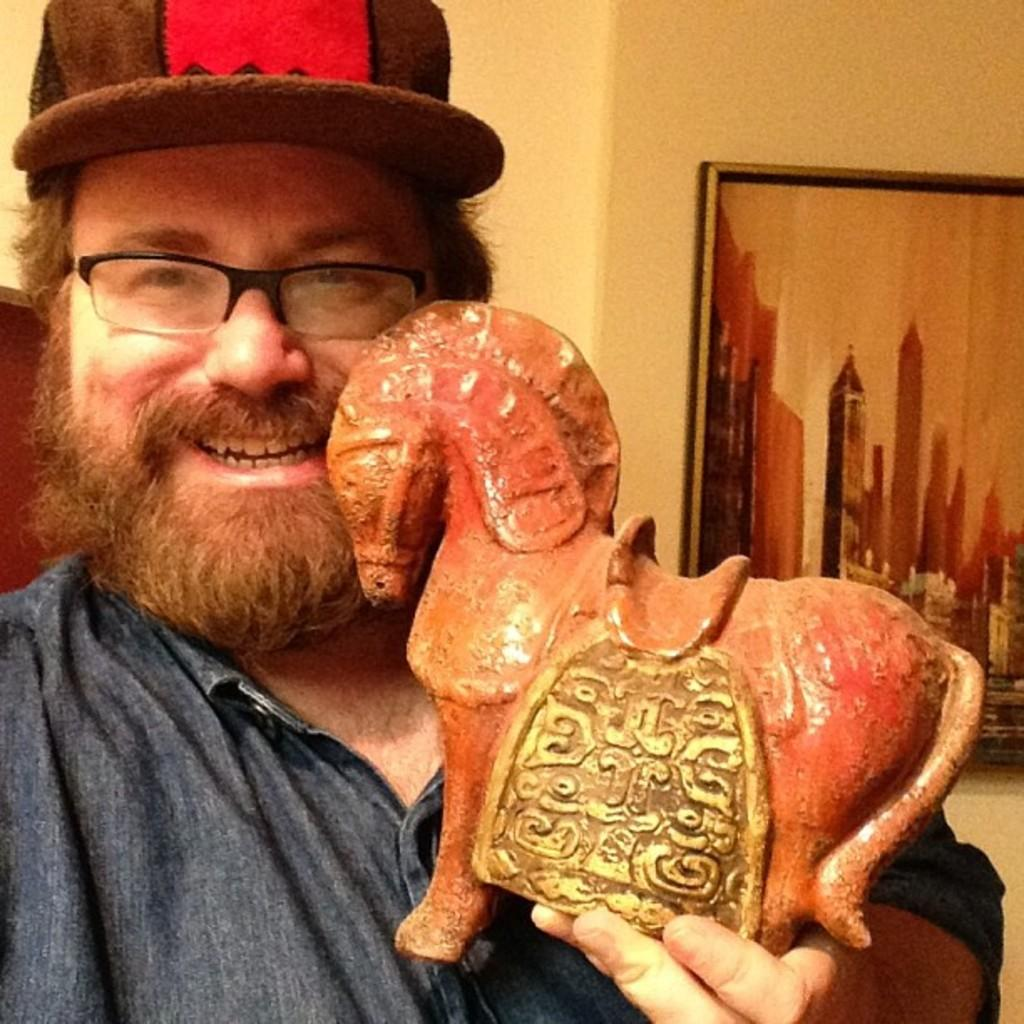Who or what is present in the image? There is a person in the image. What is the person holding in the image? The person is holding a horse toy. What type of headwear is the person wearing? The person is wearing a cap. How is the image displayed? The image is framed. What color is the wall on which the frame is attached? The frame is attached to a cream-colored wall. What type of wheel can be seen in the image? There is no wheel present in the image. Can you describe the spade that the person is using in the image? There is no spade present in the image; the person is holding a horse toy. 